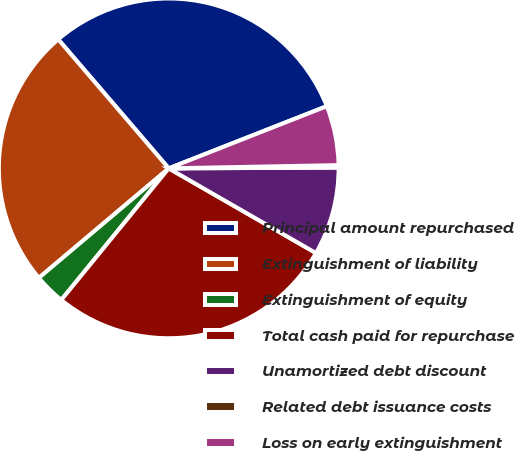Convert chart to OTSL. <chart><loc_0><loc_0><loc_500><loc_500><pie_chart><fcel>Principal amount repurchased<fcel>Extinguishment of liability<fcel>Extinguishment of equity<fcel>Total cash paid for repurchase<fcel>Unamortized debt discount<fcel>Related debt issuance costs<fcel>Loss on early extinguishment<nl><fcel>30.31%<fcel>24.88%<fcel>2.95%<fcel>27.59%<fcel>8.38%<fcel>0.23%<fcel>5.66%<nl></chart> 